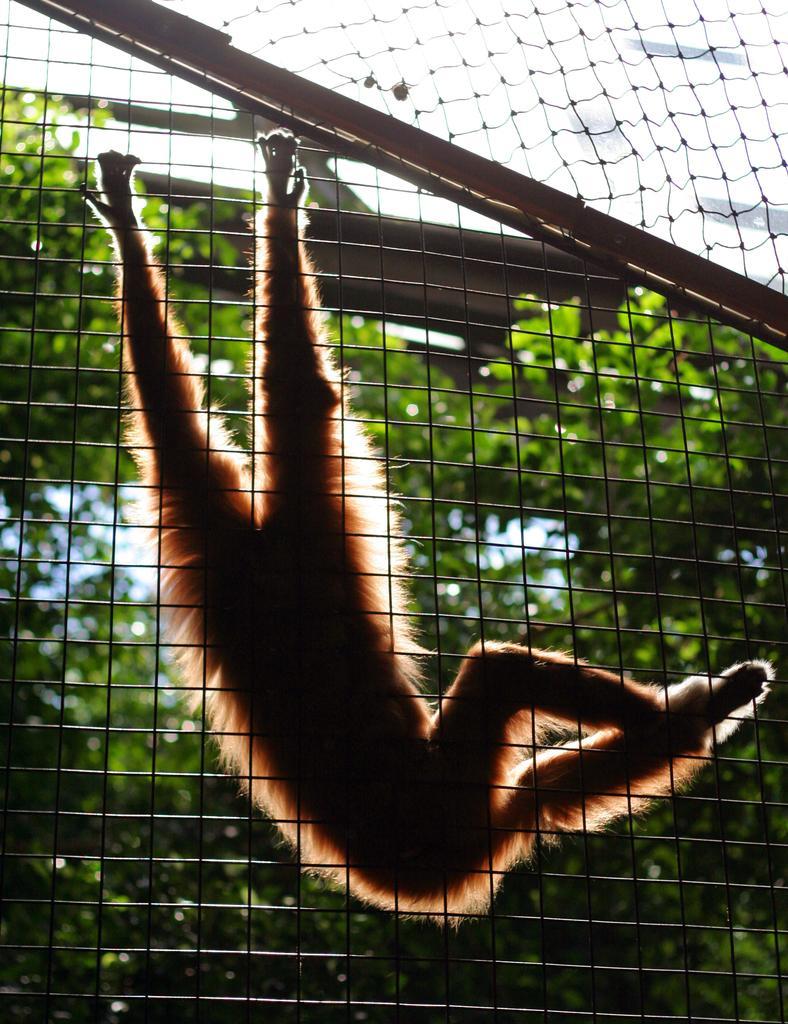In one or two sentences, can you explain what this image depicts? As we can see in the image there is a monkey with brown color holding the fence. Behind the monkey there are a lot of trees. 